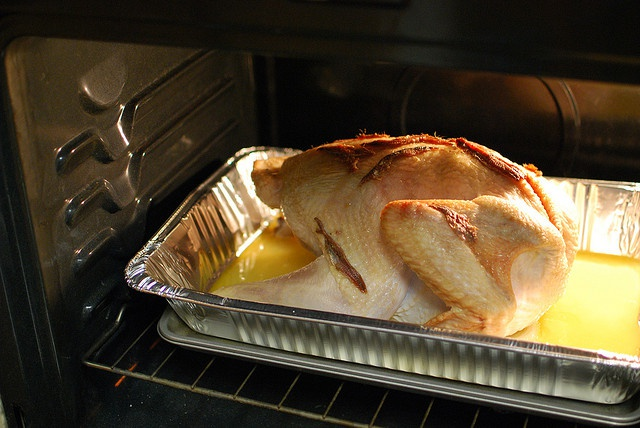Describe the objects in this image and their specific colors. I can see a oven in black, maroon, and brown tones in this image. 